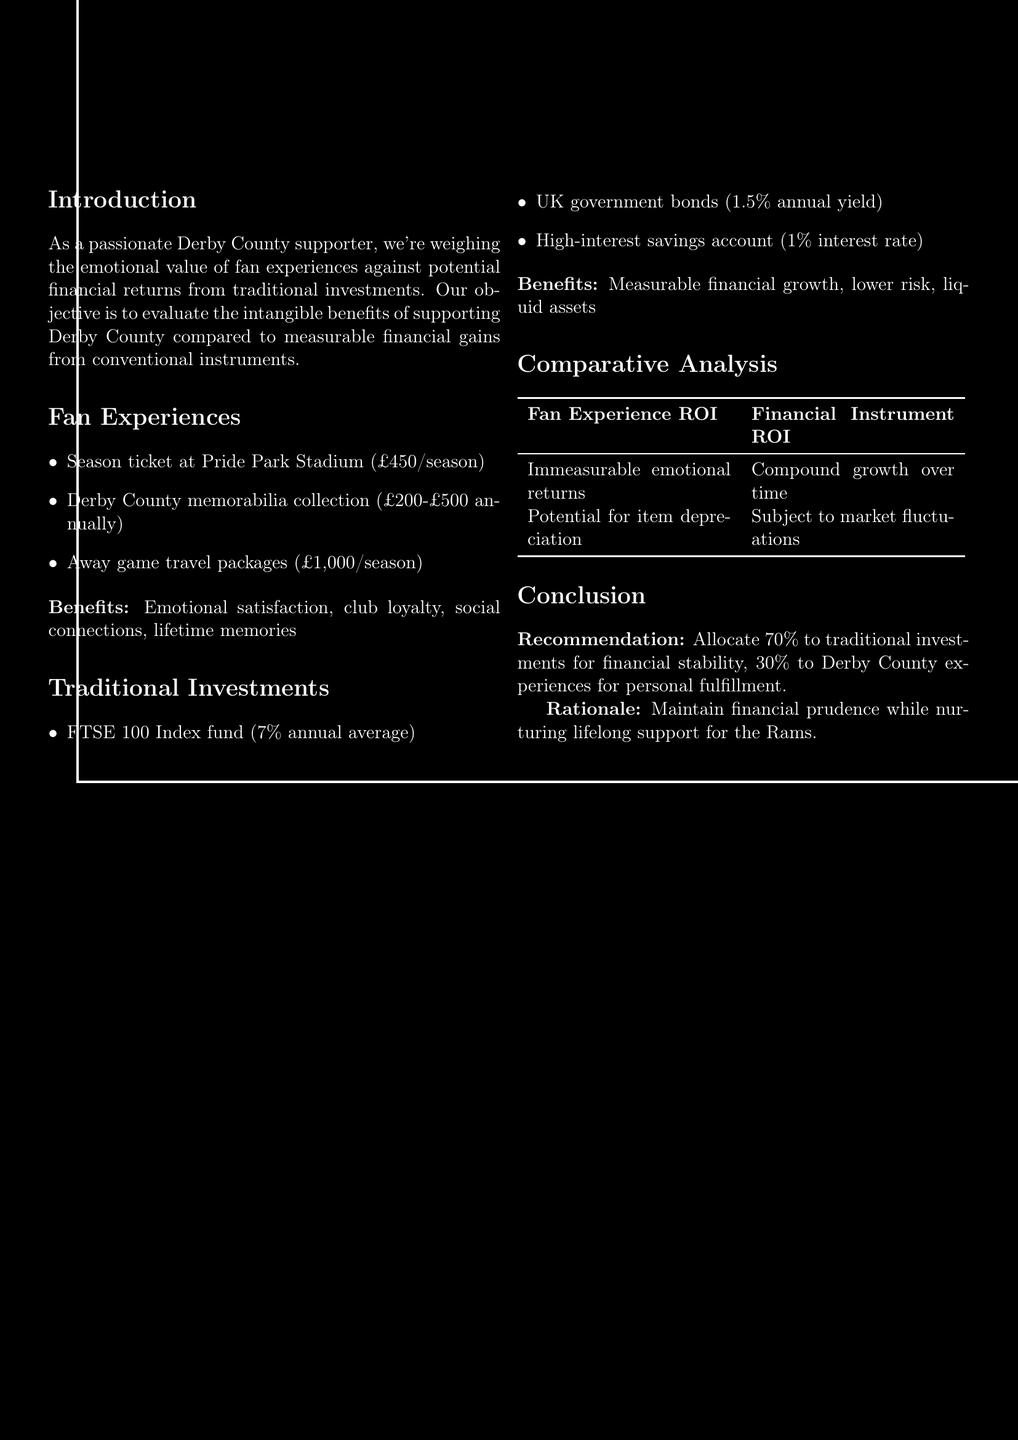What is the cost of a season ticket at Pride Park Stadium? The cost of a season ticket at Pride Park Stadium is specifically mentioned in the document.
Answer: £450 per season What percentage of allocation is recommended for traditional investments? The document provides a specific allocation percentage for traditional investments in the conclusion section.
Answer: 70% What is the annual average return for the FTSE 100 Index fund? The document lists various potential returns for different investment options, including the FTSE 100 Index fund.
Answer: 7% annual average What are the emotional benefits of Derby County fan experiences? The document lists specific emotional benefits associated with fan experiences at Derby County.
Answer: Emotional satisfaction and club loyalty What is the rationale for the investment allocation recommendation? The conclusion states the reasoning behind the investment allocation, explaining the balance achieved.
Answer: Maintain financial prudence while nurturing lifelong support for the Rams What is the cost range for a Derby County memorabilia collection? The cost range for Derby County memorabilia collection is detailed in the fan experiences section.
Answer: £200-£500 annually 